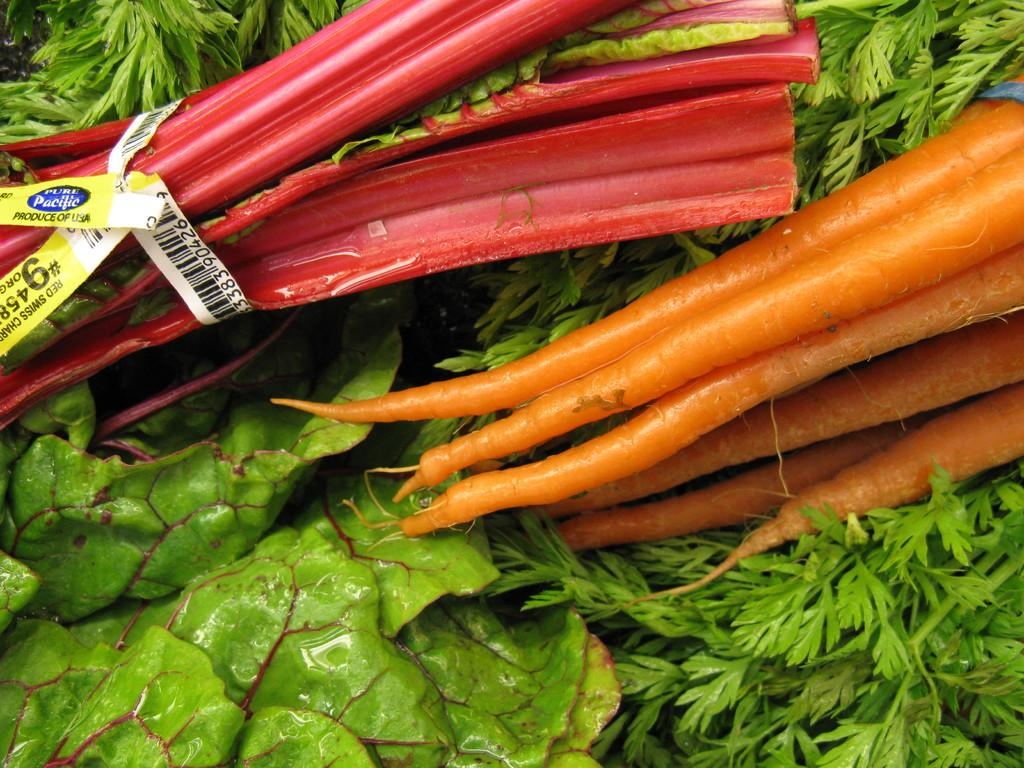What type of food is present in the image? There are vegetables in the image. Can you describe the specific type of vegetables in the image? There are leafy vegetables and carrots in the image. What color are the carrots in the image? The carrots in the image are orange in color. What song is being sung by the vegetables in the image? There are no songs or singing in the image; it features vegetables without any audible sounds. 